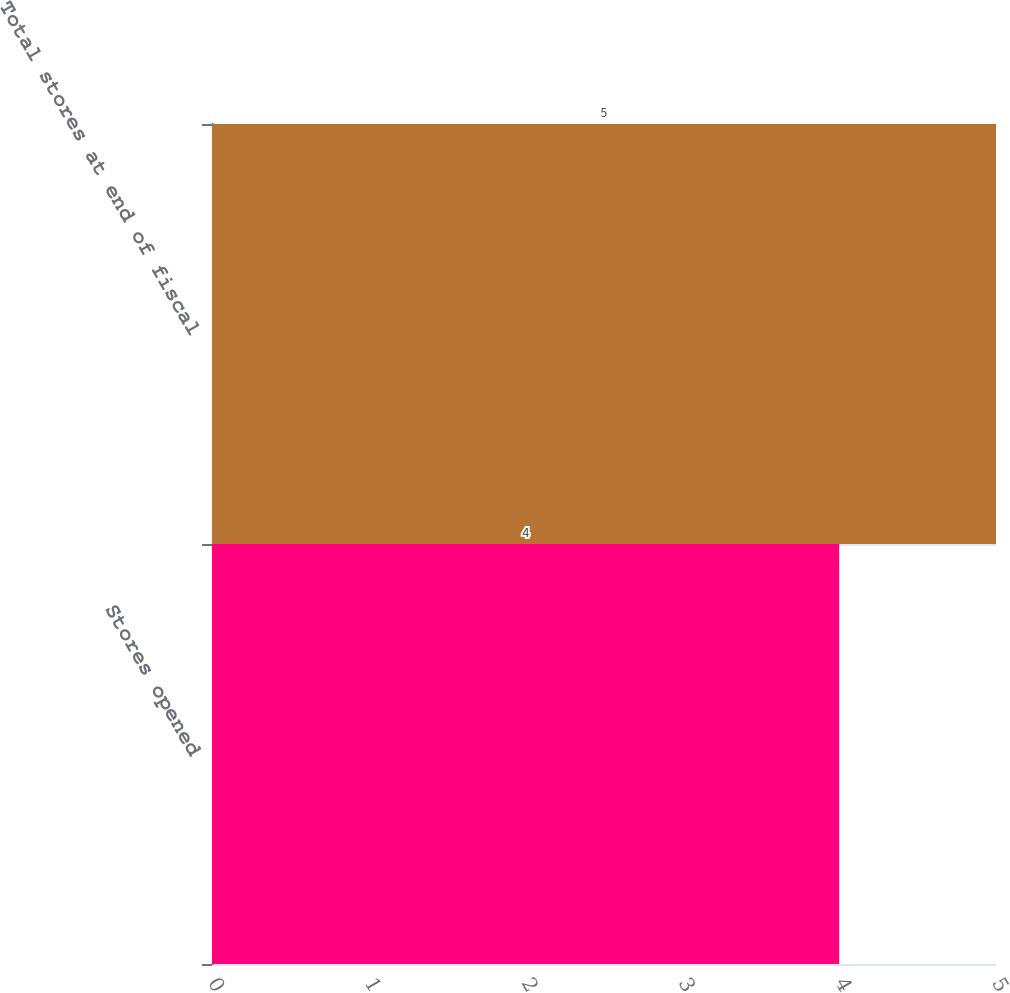<chart> <loc_0><loc_0><loc_500><loc_500><bar_chart><fcel>Stores opened<fcel>Total stores at end of fiscal<nl><fcel>4<fcel>5<nl></chart> 